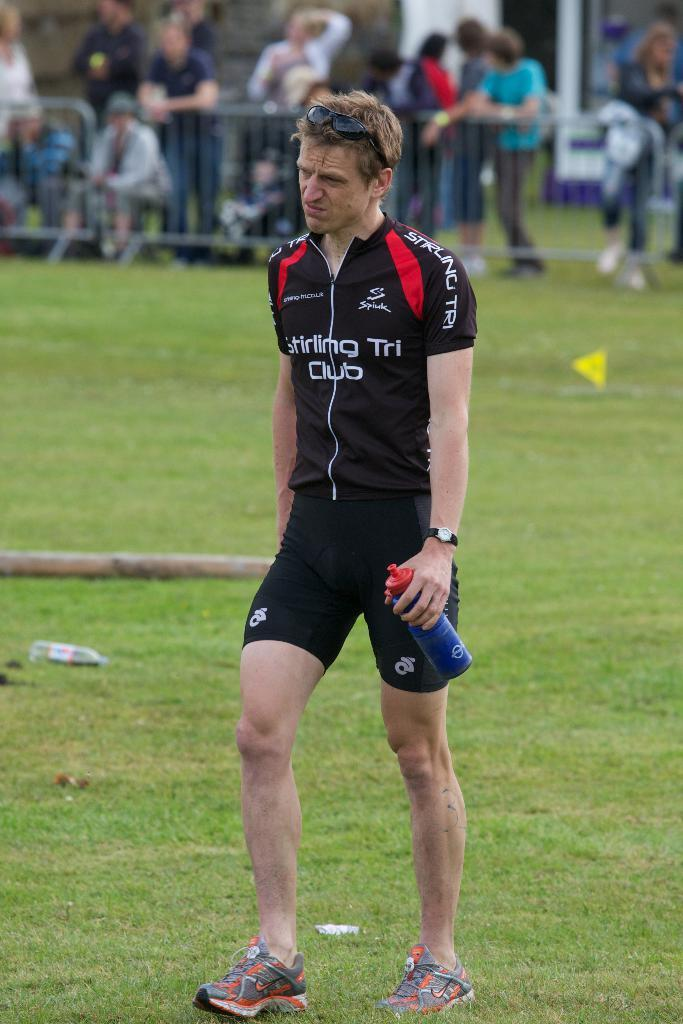<image>
Give a short and clear explanation of the subsequent image. A man with the word club on his jersey is walking across a field. 